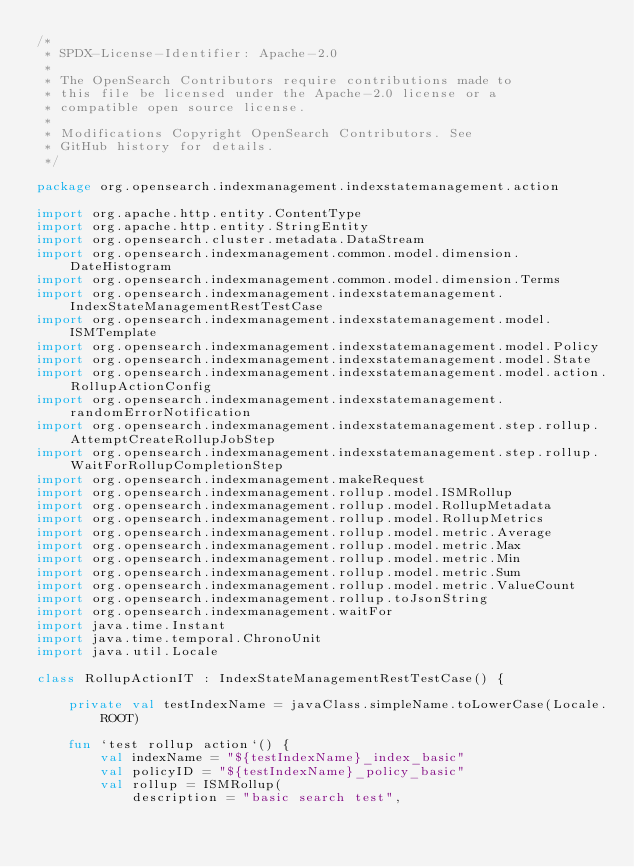<code> <loc_0><loc_0><loc_500><loc_500><_Kotlin_>/*
 * SPDX-License-Identifier: Apache-2.0
 *
 * The OpenSearch Contributors require contributions made to
 * this file be licensed under the Apache-2.0 license or a
 * compatible open source license.
 *
 * Modifications Copyright OpenSearch Contributors. See
 * GitHub history for details.
 */

package org.opensearch.indexmanagement.indexstatemanagement.action

import org.apache.http.entity.ContentType
import org.apache.http.entity.StringEntity
import org.opensearch.cluster.metadata.DataStream
import org.opensearch.indexmanagement.common.model.dimension.DateHistogram
import org.opensearch.indexmanagement.common.model.dimension.Terms
import org.opensearch.indexmanagement.indexstatemanagement.IndexStateManagementRestTestCase
import org.opensearch.indexmanagement.indexstatemanagement.model.ISMTemplate
import org.opensearch.indexmanagement.indexstatemanagement.model.Policy
import org.opensearch.indexmanagement.indexstatemanagement.model.State
import org.opensearch.indexmanagement.indexstatemanagement.model.action.RollupActionConfig
import org.opensearch.indexmanagement.indexstatemanagement.randomErrorNotification
import org.opensearch.indexmanagement.indexstatemanagement.step.rollup.AttemptCreateRollupJobStep
import org.opensearch.indexmanagement.indexstatemanagement.step.rollup.WaitForRollupCompletionStep
import org.opensearch.indexmanagement.makeRequest
import org.opensearch.indexmanagement.rollup.model.ISMRollup
import org.opensearch.indexmanagement.rollup.model.RollupMetadata
import org.opensearch.indexmanagement.rollup.model.RollupMetrics
import org.opensearch.indexmanagement.rollup.model.metric.Average
import org.opensearch.indexmanagement.rollup.model.metric.Max
import org.opensearch.indexmanagement.rollup.model.metric.Min
import org.opensearch.indexmanagement.rollup.model.metric.Sum
import org.opensearch.indexmanagement.rollup.model.metric.ValueCount
import org.opensearch.indexmanagement.rollup.toJsonString
import org.opensearch.indexmanagement.waitFor
import java.time.Instant
import java.time.temporal.ChronoUnit
import java.util.Locale

class RollupActionIT : IndexStateManagementRestTestCase() {

    private val testIndexName = javaClass.simpleName.toLowerCase(Locale.ROOT)

    fun `test rollup action`() {
        val indexName = "${testIndexName}_index_basic"
        val policyID = "${testIndexName}_policy_basic"
        val rollup = ISMRollup(
            description = "basic search test",</code> 